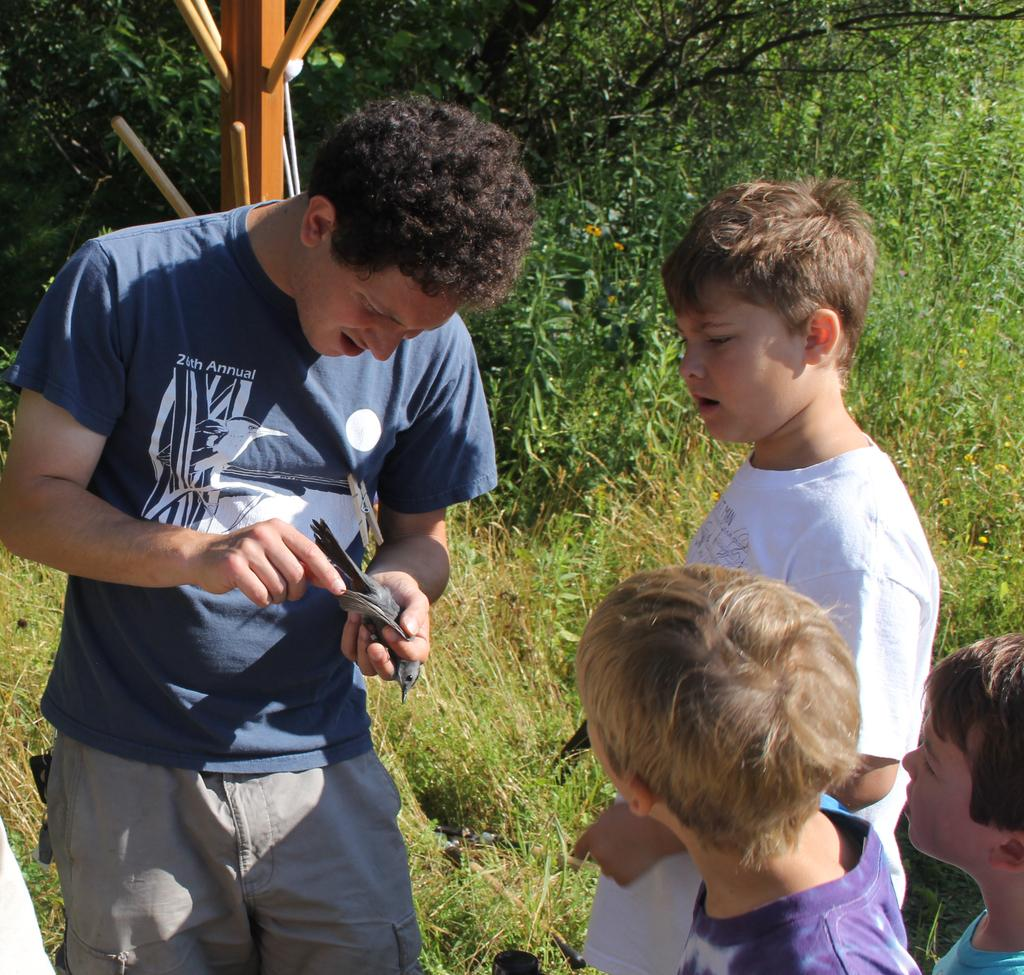What is the person in the image doing? The person is holding a bird in his hand. How many kids are in the image? There are three kids in the image. What are the kids doing? The kids are standing and watching the person. What can be seen in the background of the image? There are trees visible in the background of the image. What is the surface like in the image? There is grass on the surface in the image. What type of temper does the bird have in the image? The image does not provide information about the bird's temper. Is there a bomb visible in the image? No, there is no bomb present in the image. 